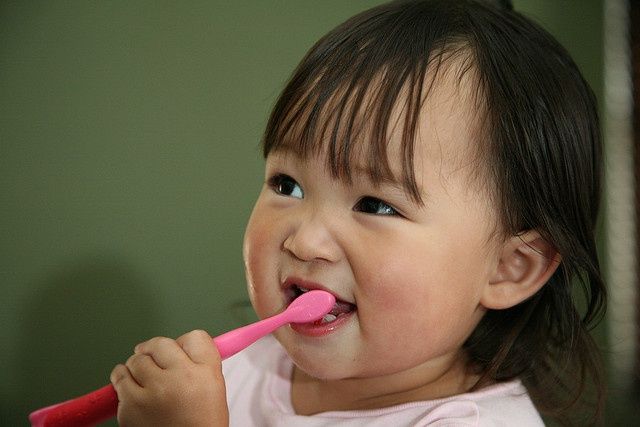Describe the objects in this image and their specific colors. I can see people in black, gray, and tan tones and toothbrush in black, salmon, maroon, and brown tones in this image. 